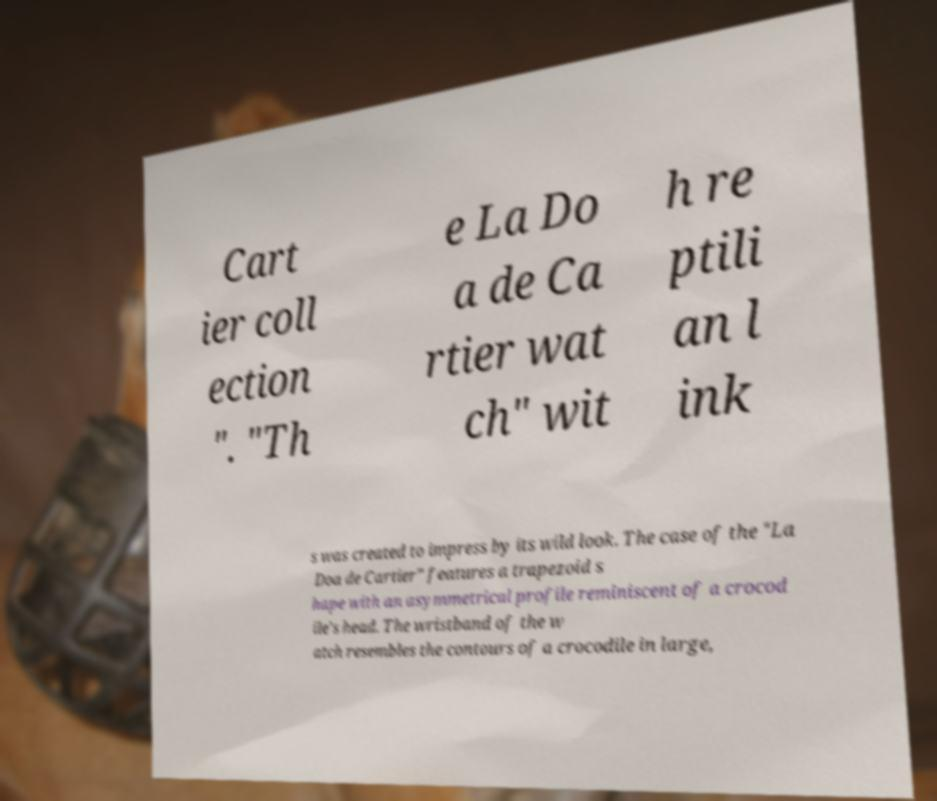Please identify and transcribe the text found in this image. Cart ier coll ection ". "Th e La Do a de Ca rtier wat ch" wit h re ptili an l ink s was created to impress by its wild look. The case of the "La Doa de Cartier" features a trapezoid s hape with an asymmetrical profile reminiscent of a crocod ile's head. The wristband of the w atch resembles the contours of a crocodile in large, 